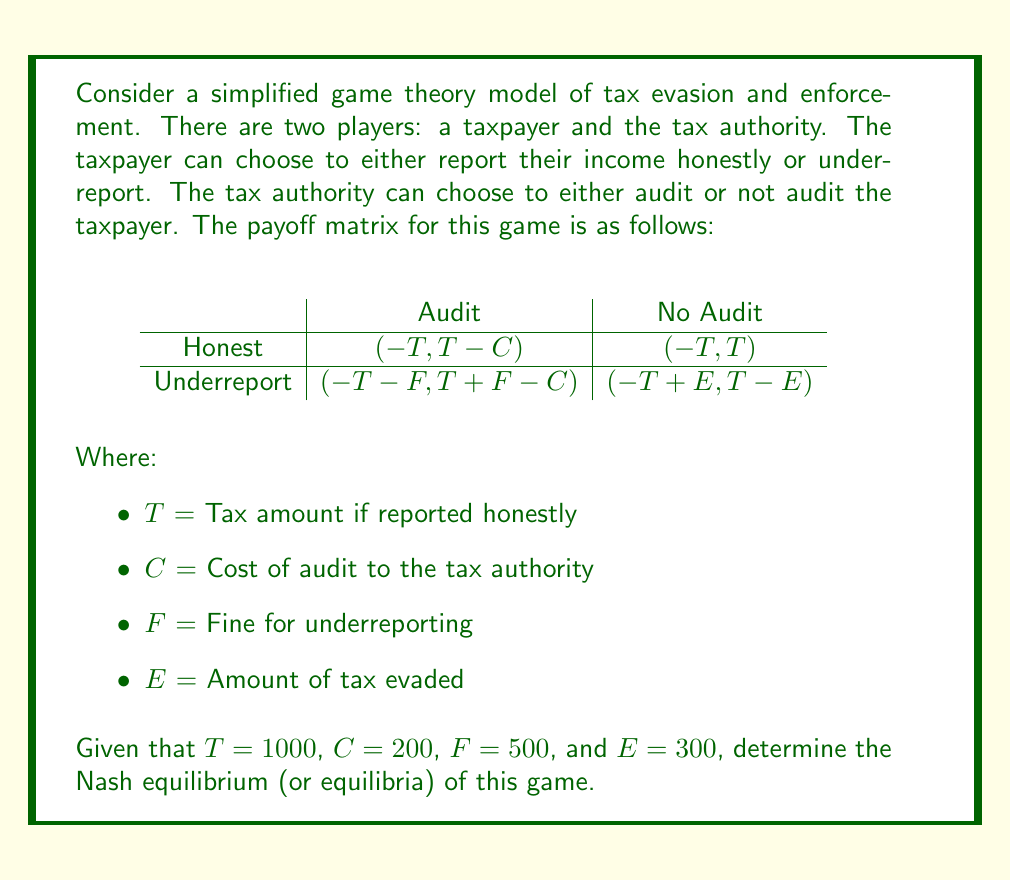Could you help me with this problem? To find the Nash equilibrium, we need to analyze each player's best response to the other player's strategy.

1. Replace the variables with the given values in the payoff matrix:

$$
\begin{array}{c|c|c}
 & \text{Audit} & \text{No Audit} \\
\hline
\text{Honest} & (-1000, 800) & (-1000, 1000) \\
\hline
\text{Underreport} & (-1500, 1300) & (-700, 700) \\
\end{array}
$$

2. Analyze the taxpayer's strategies:
   - If the tax authority audits, the taxpayer prefers to be honest (-1000 > -1500)
   - If the tax authority doesn't audit, the taxpayer prefers to underreport (-700 > -1000)

3. Analyze the tax authority's strategies:
   - If the taxpayer is honest, the tax authority prefers not to audit (1000 > 800)
   - If the taxpayer underreports, the tax authority prefers to audit (1300 > 700)

4. Look for pure strategy Nash equilibria:
   There is no cell where both players are playing their best response to the other's strategy.

5. Calculate mixed strategy equilibrium:
   Let $p$ be the probability that the taxpayer reports honestly, and $q$ be the probability that the tax authority audits.

   For the taxpayer to be indifferent:
   $-1000q + (-1000)(1-q) = -1500q + (-700)(1-q)$
   $-1000 = -1500q - 700 + 700q$
   $-300 = -800q$
   $q = 3/8 = 0.375$

   For the tax authority to be indifferent:
   $800p + 1300(1-p) = 1000p + 700(1-p)$
   $800p + 1300 - 1300p = 1000p + 700 - 700p$
   $600 = 1200p$
   $p = 1/2 = 0.5$

6. The Nash equilibrium is a mixed strategy where:
   - The taxpayer reports honestly with probability 0.5 and underreports with probability 0.5
   - The tax authority audits with probability 0.375 and doesn't audit with probability 0.625
Answer: The Nash equilibrium is a mixed strategy equilibrium where the taxpayer reports honestly with probability 0.5 and underreports with probability 0.5, while the tax authority audits with probability 0.375 and doesn't audit with probability 0.625. 